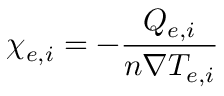Convert formula to latex. <formula><loc_0><loc_0><loc_500><loc_500>\chi _ { e , i } = - \frac { Q _ { e , i } } { n \nabla T _ { e , i } }</formula> 